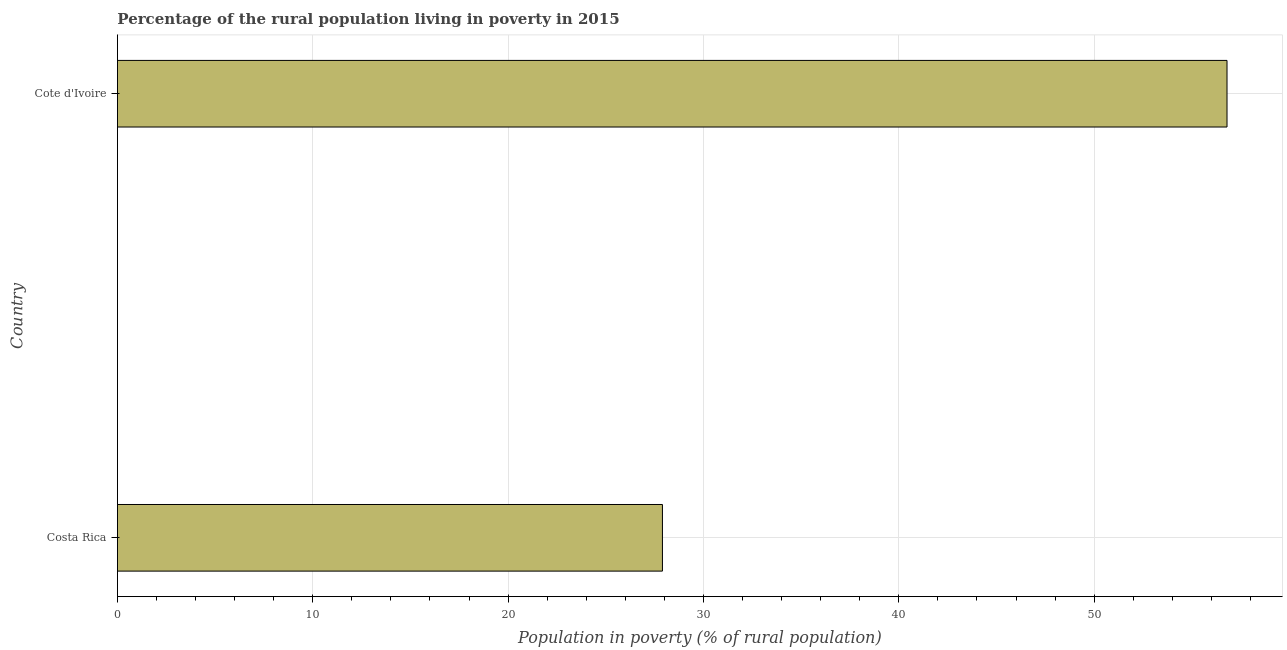What is the title of the graph?
Make the answer very short. Percentage of the rural population living in poverty in 2015. What is the label or title of the X-axis?
Your response must be concise. Population in poverty (% of rural population). What is the percentage of rural population living below poverty line in Cote d'Ivoire?
Give a very brief answer. 56.8. Across all countries, what is the maximum percentage of rural population living below poverty line?
Your answer should be very brief. 56.8. Across all countries, what is the minimum percentage of rural population living below poverty line?
Offer a terse response. 27.9. In which country was the percentage of rural population living below poverty line maximum?
Your answer should be very brief. Cote d'Ivoire. What is the sum of the percentage of rural population living below poverty line?
Offer a very short reply. 84.7. What is the difference between the percentage of rural population living below poverty line in Costa Rica and Cote d'Ivoire?
Keep it short and to the point. -28.9. What is the average percentage of rural population living below poverty line per country?
Offer a terse response. 42.35. What is the median percentage of rural population living below poverty line?
Offer a very short reply. 42.35. What is the ratio of the percentage of rural population living below poverty line in Costa Rica to that in Cote d'Ivoire?
Give a very brief answer. 0.49. Is the percentage of rural population living below poverty line in Costa Rica less than that in Cote d'Ivoire?
Make the answer very short. Yes. In how many countries, is the percentage of rural population living below poverty line greater than the average percentage of rural population living below poverty line taken over all countries?
Provide a succinct answer. 1. How many bars are there?
Offer a terse response. 2. Are the values on the major ticks of X-axis written in scientific E-notation?
Your answer should be compact. No. What is the Population in poverty (% of rural population) of Costa Rica?
Your answer should be very brief. 27.9. What is the Population in poverty (% of rural population) in Cote d'Ivoire?
Make the answer very short. 56.8. What is the difference between the Population in poverty (% of rural population) in Costa Rica and Cote d'Ivoire?
Keep it short and to the point. -28.9. What is the ratio of the Population in poverty (% of rural population) in Costa Rica to that in Cote d'Ivoire?
Keep it short and to the point. 0.49. 